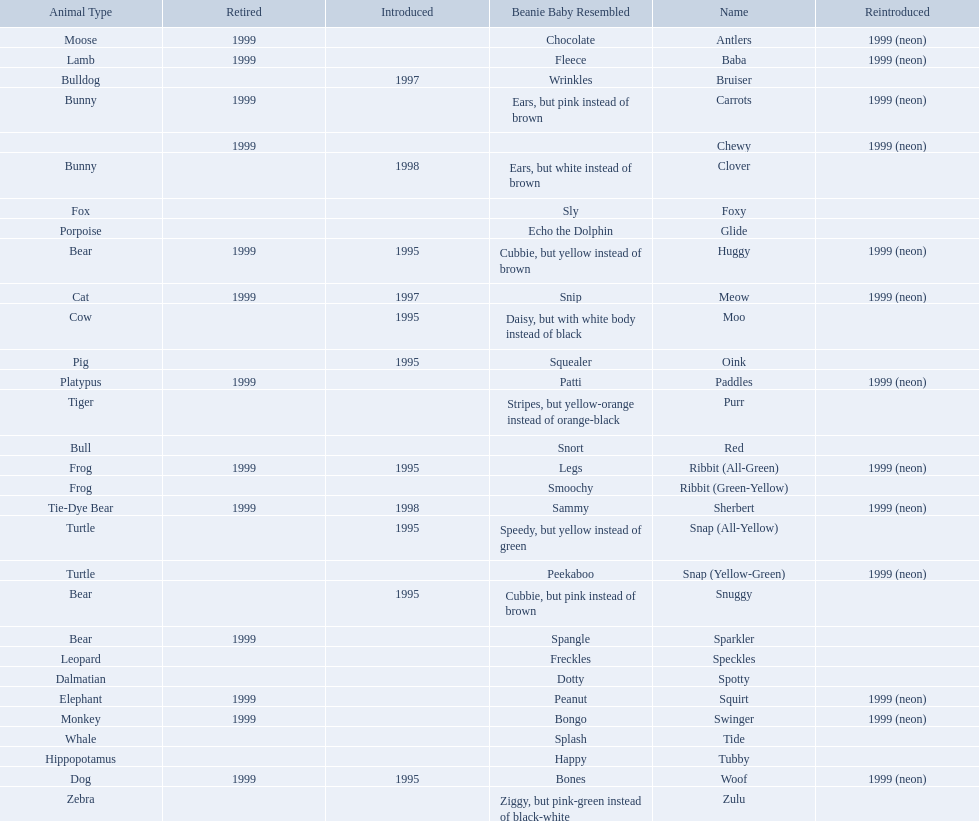What are the types of pillow pal animals? Antlers, Moose, Lamb, Bulldog, Bunny, , Bunny, Fox, Porpoise, Bear, Cat, Cow, Pig, Platypus, Tiger, Bull, Frog, Frog, Tie-Dye Bear, Turtle, Turtle, Bear, Bear, Leopard, Dalmatian, Elephant, Monkey, Whale, Hippopotamus, Dog, Zebra. Of those, which is a dalmatian? Dalmatian. What is the name of the dalmatian? Spotty. 